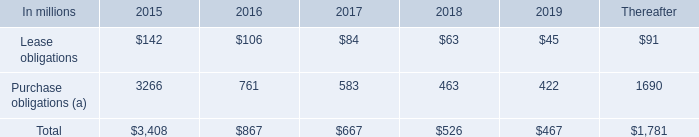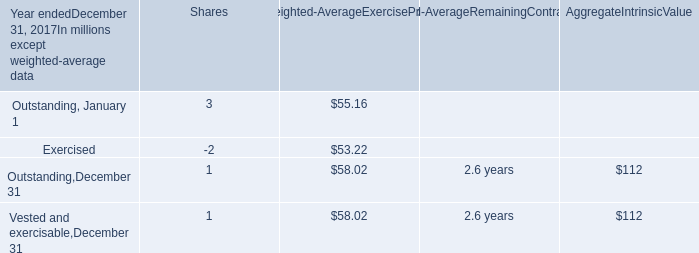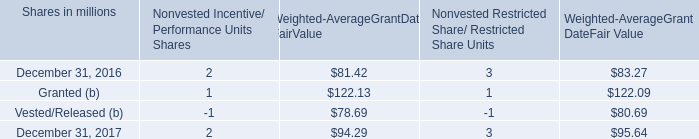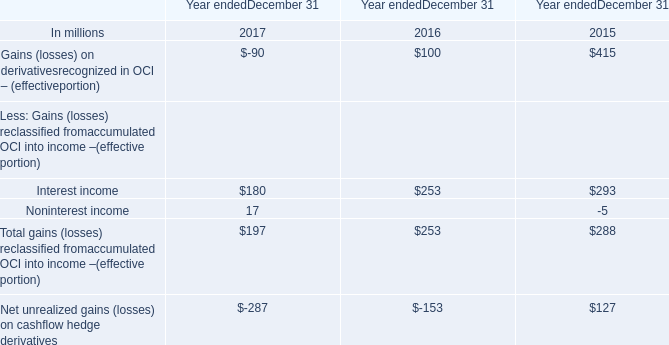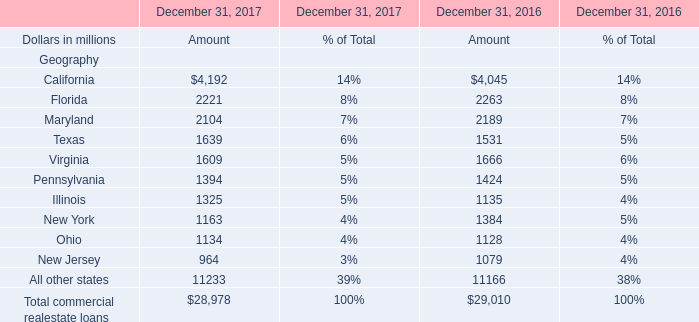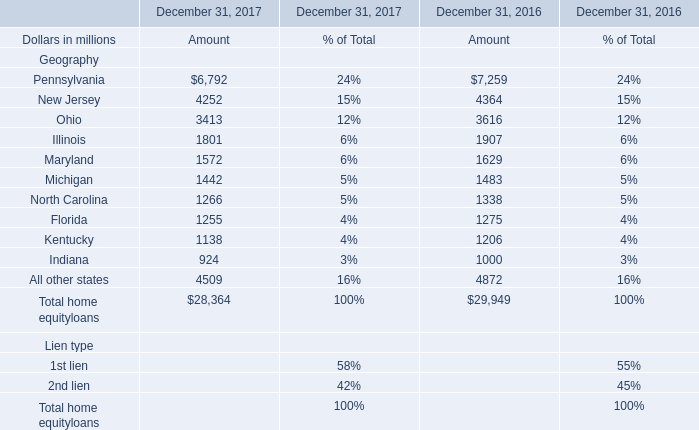What's the sum of all home equity loans that are greater than 3000 in 2017? (in million) 
Computations: (((6792 + 4252) + 3413) + 4509)
Answer: 18966.0. 